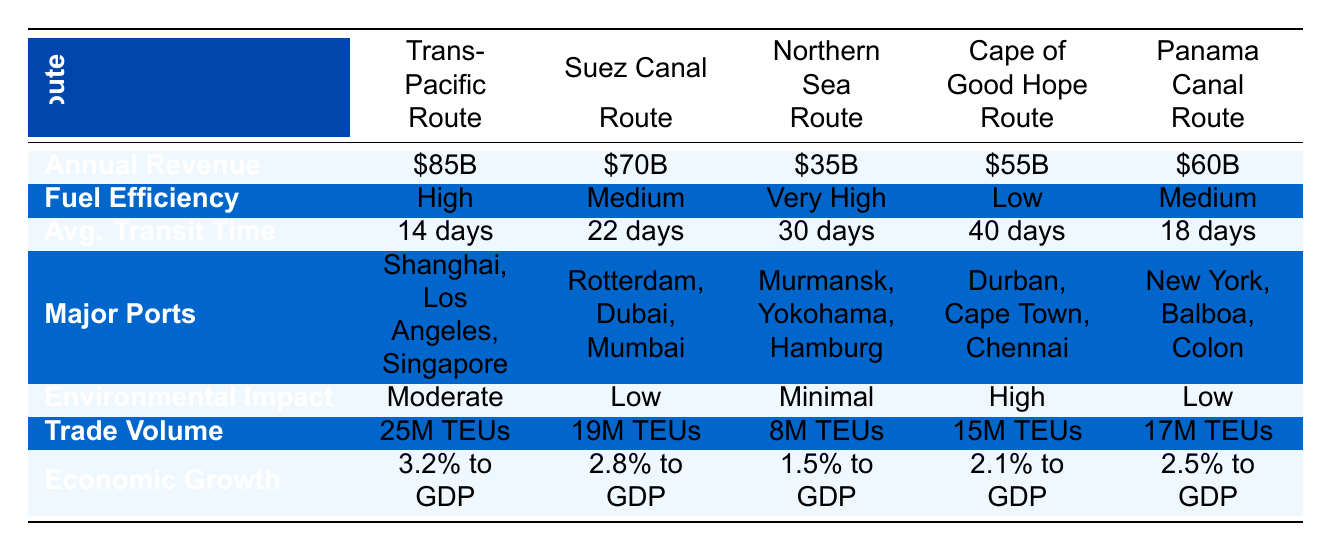What is the annual revenue of the Trans-Pacific Route? The table lists the annual revenue for each shipping route. Looking at the row for the Trans-Pacific Route, the annual revenue is specifically stated as $85 billion.
Answer: $85 billion Which shipping route has the highest trade volume? The trade volume for each route is provided in the table. Comparing the values, the Trans-Pacific Route has a trade volume of 25 million TEUs, which is higher than all others in the table.
Answer: Trans-Pacific Route What is the average transit time for the Suez Canal Route compared to the Northern Sea Route? The average transit time for the Suez Canal Route is 22 days, while for the Northern Sea Route, it is 30 days. By comparing these two values, one can see that the Suez Canal Route has a shorter average transit time.
Answer: Suez Canal Route has a shorter time Which route contributes the least to economic growth? The economic growth contributions for each route are provided in terms of percentage to GDP. Looking at the list, the Northern Sea Route contributes 1.5% to GDP, which is the lowest among the options.
Answer: Northern Sea Route Is the environmental impact of the Panama Canal Route higher than that of the Cape of Good Hope Route? The environmental impacts are categorized into low, moderate, high, and minimal. The Panama Canal Route has a low environmental impact, while the Cape of Good Hope Route has a high environmental impact. Therefore, the environmental impact of the Panama Canal Route is not higher; it is actually lower.
Answer: No Which shipping route has both low environmental impact and high annual revenue? Analyzing the table, the Suez Canal Route and the Panama Canal Route both have a low environmental impact. However, the Suez Canal Route generates $70 billion, while the Panama Canal Route generates $60 billion. Thus, the Suez Canal Route has high annual revenue with low environmental impact.
Answer: Suez Canal Route What are the major ports for the Cape of Good Hope Route? The table lists the major ports under each shipping route. For the Cape of Good Hope Route, the major ports mentioned are Durban, Cape Town, and Chennai.
Answer: Durban, Cape Town, Chennai Calculate the difference in trade volume between the Trans-Pacific Route and the Northern Sea Route. The trade volume of the Trans-Pacific Route is 25 million TEUs, and for the Northern Sea Route, it is 8 million TEUs. The difference is calculated as 25 - 8 = 17 million TEUs.
Answer: 17 million TEUs What is the average economic growth contribution of the five routes? To find the average economic growth contribution, first convert the percentages to decimals: 3.2%, 2.8%, 1.5%, 2.1%, and 2.5%. The sum equals 12.1%. Dividing by 5 gives an average of 12.1% / 5 = 2.42%.
Answer: 2.42% Which route has the most major ports listed? The Trans-Pacific Route, Suez Canal Route, Northern Sea Route, Cape of Good Hope Route, and Panama Canal Route each have three major ports listed. Therefore, all the routes have the same number of major ports.
Answer: All routes have three major ports listed 